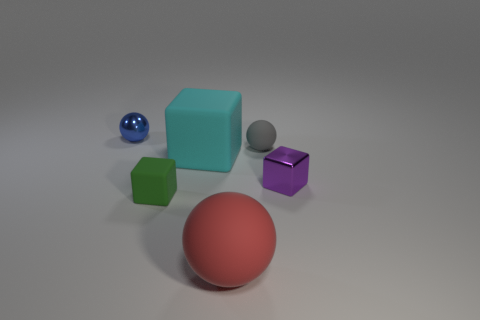How do the shadows in the image inform us about the light source? The shadows cast by the objects in the image suggest that the light source is positioned above and slightly to the right. The shadows are relatively soft and diffused, indicating the light source may be large or there could be some ambient lighting present as well. The direction and length of the shadows help us understand the spatial relationship between the objects and the light source. Can you tell if there's more than one light source? Based on the way the shadows are cast and the highlights on the objects, it seems likely that there's a primary light source. However, the absence of very sharp or highly contrasted shadows might suggest the presence of supplementary ambient lighting or another diffuse light source to soften the shadows. 